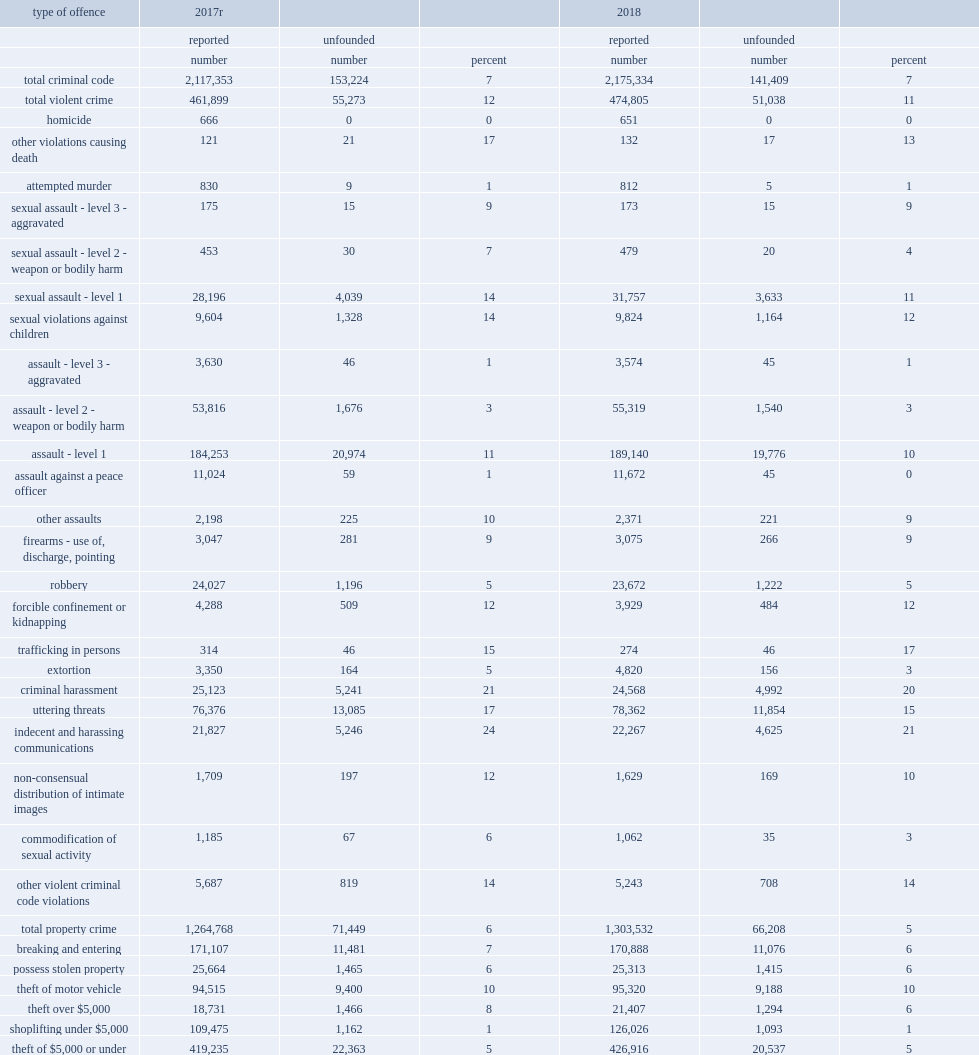In 2018, what was the percent of level 1 sexual assaults reported to police were classified as unfounded? 11.0. In 2017, how many percentages decrease of level 1 sexual assaults reported to police were classified as unfounded? 14.0. In 2018, how many percent of level 1 assault incidents were classified as unfounded? 10.0. In 2017, how many percent of a decrease of level 1 assault incidents were classified as unfounded? 11.0. 